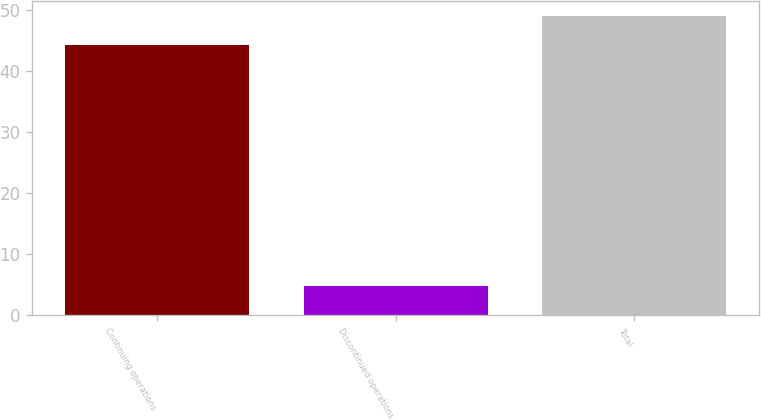<chart> <loc_0><loc_0><loc_500><loc_500><bar_chart><fcel>Continuing operations<fcel>Discontinued operations<fcel>Total<nl><fcel>44.3<fcel>4.8<fcel>49.1<nl></chart> 